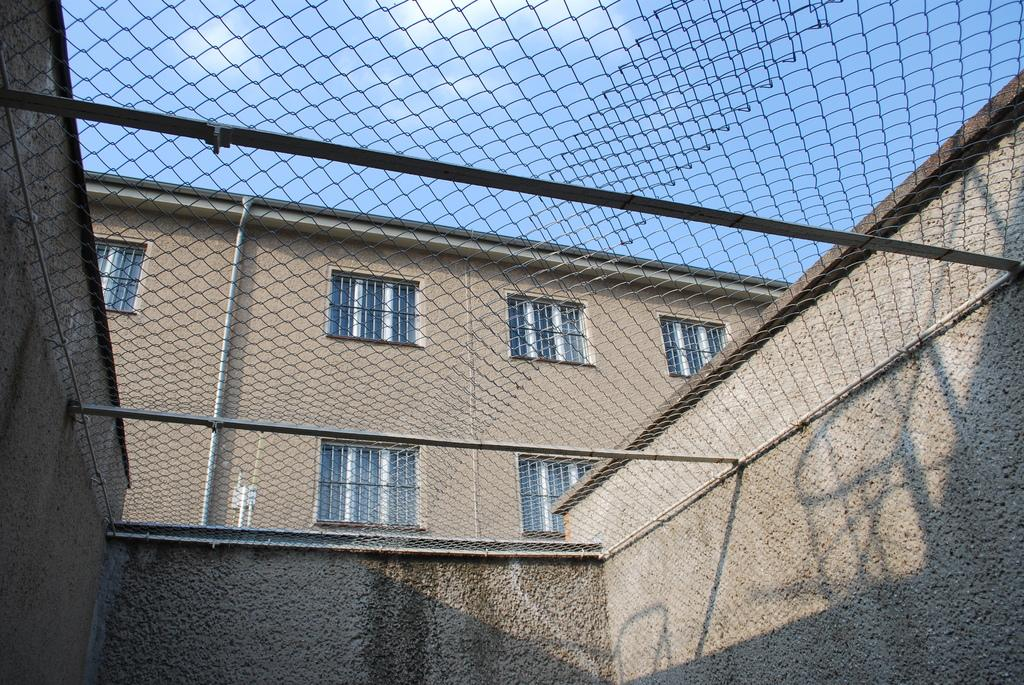What type of structure can be seen in the image? There is fencing in the image. What is located behind the fencing? The fencing is in front of a building. How many windows are visible on the building? The building has multiple windows. What is visible in the sky in the image? There are clouds visible in the sky. How many beetles can be seen crawling on the building in the image? There are no beetles visible in the image; it only features fencing, a building, and clouds in the sky. Who is the partner of the person standing next to the building in the image? There is no person standing next to the building in the image, so it is impossible to determine who their partner might be. 